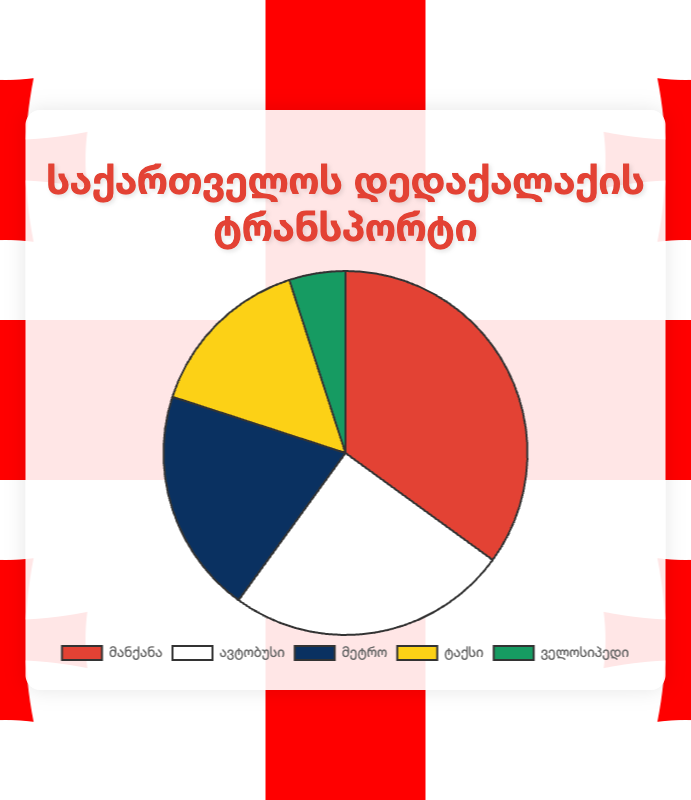Which mode of transportation has the highest percentage? The mode of transportation with the highest percentage is "Car" with a percentage of 35%.
Answer: Car What is the sum of the percentages of those who prefer Car and Metro? Add the percentage of those who prefer Car (35%) to the percentage of those who prefer Metro (20%) to get the total: 35 + 20 = 55.
Answer: 55 Which mode of transportation has the smallest percentage? The mode of transportation with the smallest percentage is "Bicycle" with a percentage of 5%.
Answer: Bicycle Is the percentage of people who prefer the Bus greater than the percentage who prefer the Taxi? Compare the percentage of those who prefer the Bus (25%) to those who prefer the Taxi (15%). 25 is greater than 15.
Answer: Yes What is the average percentage for all modes of transportation? Sum the percentages of all modes: 35 + 25 + 20 + 15 + 5 = 100. Then divide by the number of modes, which is 5: 100 / 5 = 20.
Answer: 20 Which two modes of transportation together make up 50% of the total? By examining pairs: Car (35%) + Taxi (15%) = 50%, so Car and Taxi together make up 50%.
Answer: Car and Taxi Compare the sum of the percentages of those who prefer the Bus and Metro to those who prefer the Taxi and Bicycle. Which sum is greater? Sum for Bus and Metro: 25 + 20 = 45. Sum for Taxi and Bicycle: 15 + 5 = 20. 45 is greater than 20.
Answer: Bus and Metro If the sum of all percentages adds up to 100%, how many percentage points less is the Bicycle compared to the Car? Subtract the Bicycle percentage (5%) from the Car percentage (35%): 35 - 5 = 30.
Answer: 30 What is the difference in percentages between the most preferred mode and the least preferred mode? Subtract the percentage of the least preferred mode (Bicycle, 5%) from the most preferred mode (Car, 35%): 35 - 5 = 30.
Answer: 30 